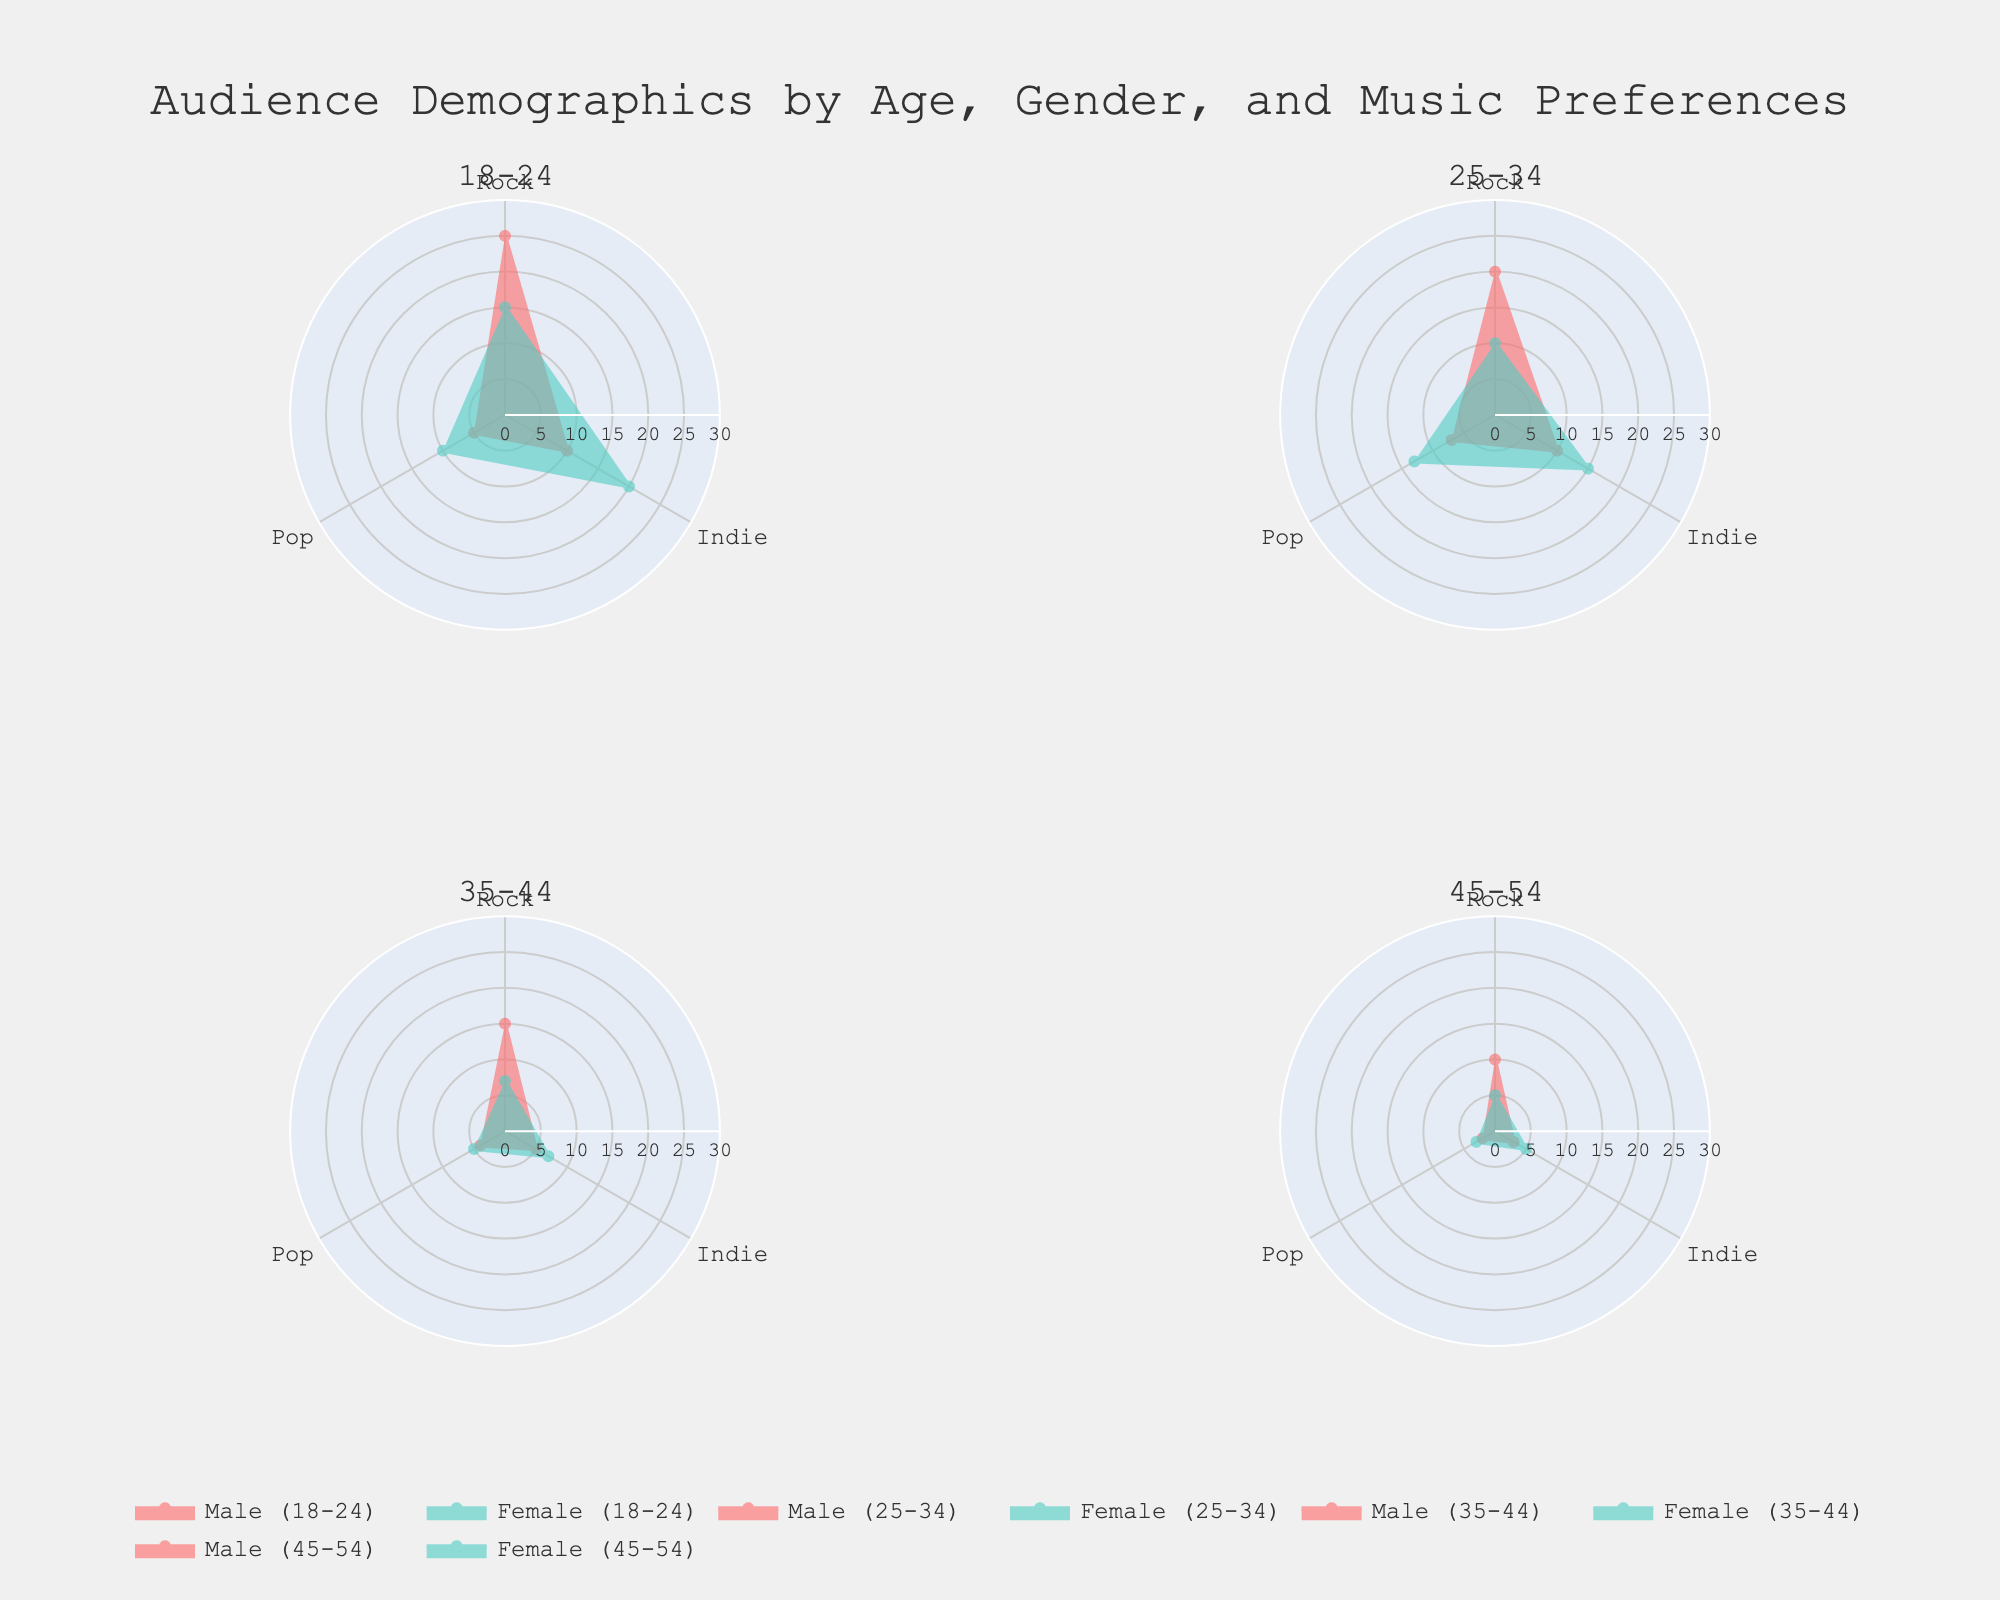What is the highest percentage genre preference for females aged 18-24? We look at the subplot for the 18-24 age group and identify the colored areas for females. Among Rock, Indie, and Pop, the Indie genre has the highest percentage for females at 20%.
Answer: Indie What is the total percentage of males aged 35-44 who prefer Rock and Indie combined? We first find the percentage of males who prefer Rock (15%) and Indie (5%) in the 35-44 age group. Adding these gives 15 + 5 = 20.
Answer: 20% Which age group shows the smallest gender gap in Rock music preference? We compare the differences between male and female percentages for Rock preferences in each age group. The 35-44 age group shows the smallest difference, with males at 15% and females at 7%, a gap of 8 percentage points.
Answer: 35-44 Do males or females aged 25-34 have higher combined preferences for Rock and Pop genres? For males, the combined percentage for Rock (20%) and Pop (7%) is 27%. For females, it is 10% (Rock) + 13% (Pop) = 23%. Therefore, males have higher combined preferences.
Answer: Males Which gender has a higher preference for Indie music in the 45-54 age group? By comparing the percentages for Indie music in the 45-54 age group, males have 3% and females have 5%. Thus, females have a higher preference.
Answer: Females In which age group do females prefer Pop music the most? We look at the highest percentage values for Pop music across all age groups for females. The 25-34 age group has the highest percentage at 13%.
Answer: 25-34 How does the preference for Rock music among males change from the 18-24 age group to the 35-44 age group? We track the percentages for males across the age groups: 25% (18-24), 20% (25-34), and 15% (35-44). The preference decreases gradually.
Answer: Decreases What is the difference between the highest genre preference and the lowest genre preference for males aged 25-34? For males aged 25-34, the percentages are Rock (20%), Indie (10%), and Pop (7%). The difference between the highest (Rock) and the lowest (Pop) is 20 - 7 = 13.
Answer: 13 Do any age groups show a higher preference for Pop music than Rock music for females? We compare percentages between Pop and Rock for females in each age group. Only the 25-34 age group shows higher Pop preference (13%) over Rock (10%).
Answer: 25-34 What is the average preference percentage for all genres for females aged 35-44? We add the percentages for females in the 35-44 age group: Rock (7%), Indie (7%), and Pop (5%), which sums to 19. Dividing by 3 (number of genres) gives an average of 19 / 3 ≈ 6.33.
Answer: Approximately 6.33 